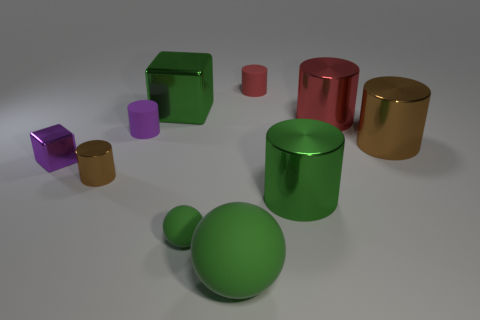Subtract all green cylinders. How many cylinders are left? 5 Subtract all small red cylinders. How many cylinders are left? 5 Subtract all yellow cylinders. Subtract all gray cubes. How many cylinders are left? 6 Subtract all cubes. How many objects are left? 8 Subtract 0 blue balls. How many objects are left? 10 Subtract all purple blocks. Subtract all big green balls. How many objects are left? 8 Add 9 large brown things. How many large brown things are left? 10 Add 5 large green things. How many large green things exist? 8 